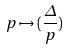<formula> <loc_0><loc_0><loc_500><loc_500>p \mapsto ( \frac { \Delta } { p } )</formula> 